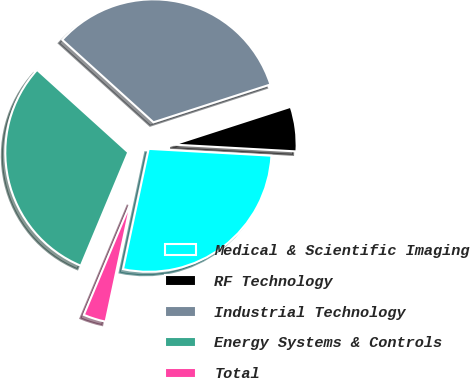Convert chart. <chart><loc_0><loc_0><loc_500><loc_500><pie_chart><fcel>Medical & Scientific Imaging<fcel>RF Technology<fcel>Industrial Technology<fcel>Energy Systems & Controls<fcel>Total<nl><fcel>27.46%<fcel>5.86%<fcel>33.32%<fcel>30.41%<fcel>2.96%<nl></chart> 